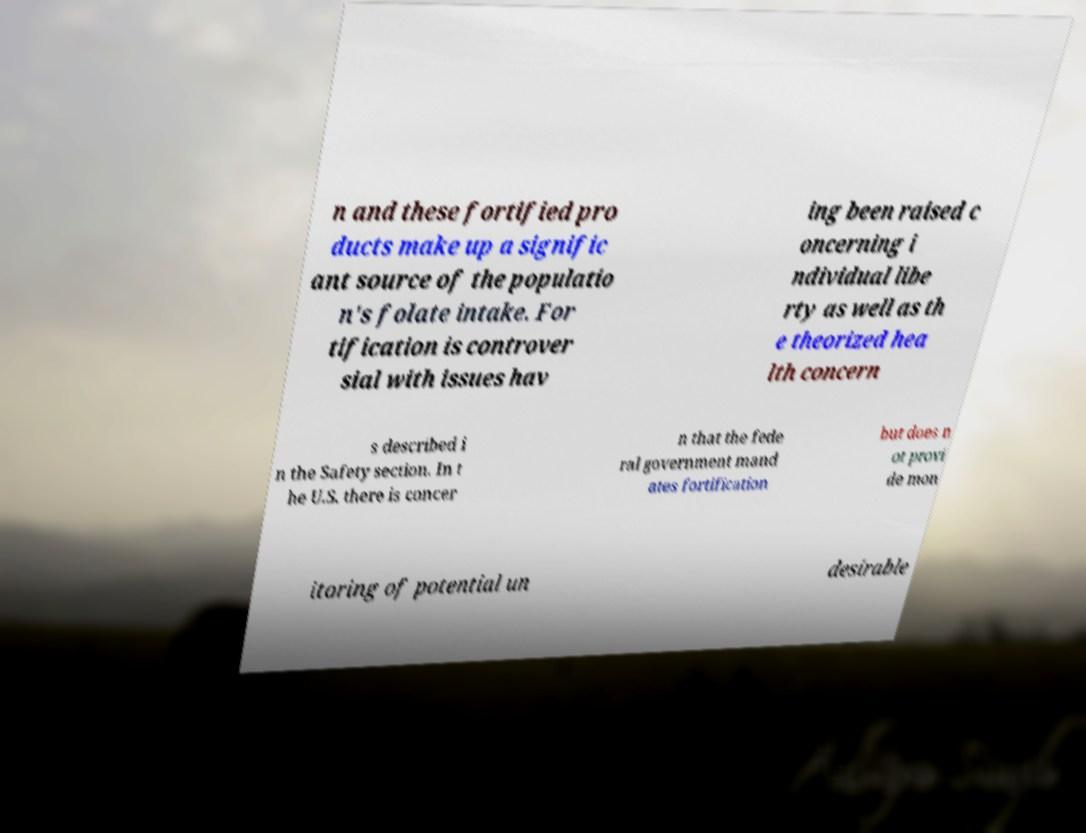Please read and relay the text visible in this image. What does it say? n and these fortified pro ducts make up a signific ant source of the populatio n's folate intake. For tification is controver sial with issues hav ing been raised c oncerning i ndividual libe rty as well as th e theorized hea lth concern s described i n the Safety section. In t he U.S. there is concer n that the fede ral government mand ates fortification but does n ot provi de mon itoring of potential un desirable 